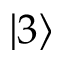<formula> <loc_0><loc_0><loc_500><loc_500>\left | 3 \right ></formula> 